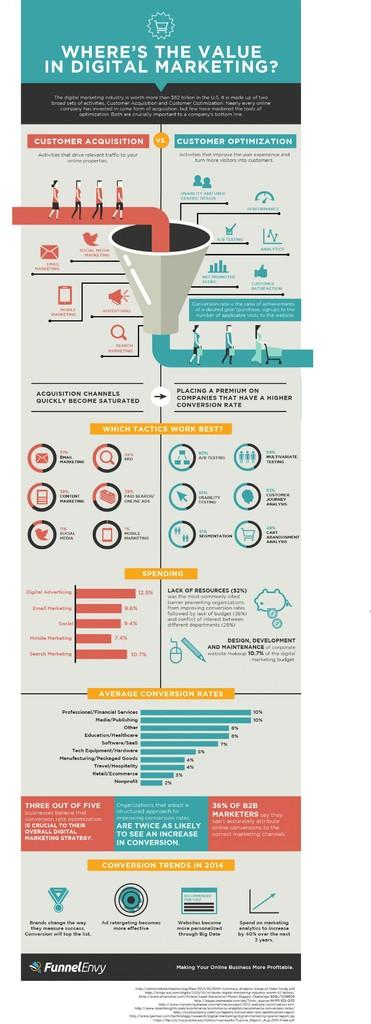What is featured in the image? There is a poster in the image. What can be seen in the pictures on the poster? The pictures on the poster contain images of people. What else is present on the poster besides the pictures? There is text on the poster. What type of shoes are the people wearing in the poster? There is no information about shoes in the image, as the poster only contains pictures of people and text. 